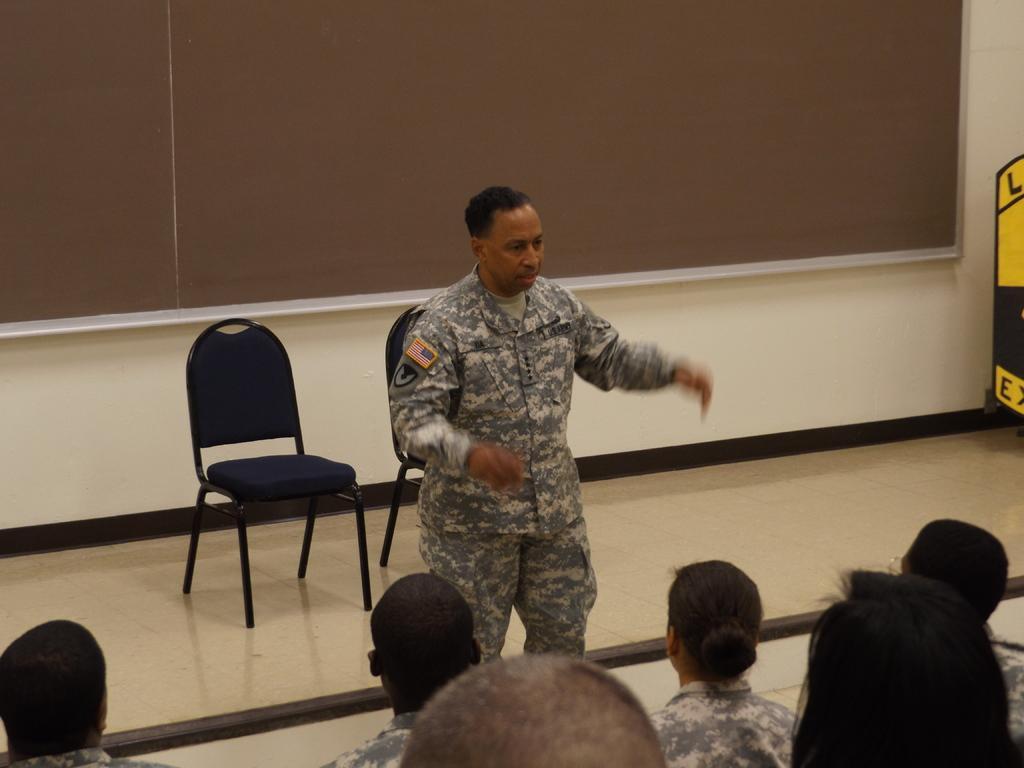In one or two sentences, can you explain what this image depicts? The person is standing and speaking and there are group of people in front of him and there are two chairs behind. 